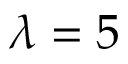Convert formula to latex. <formula><loc_0><loc_0><loc_500><loc_500>\lambda = 5</formula> 